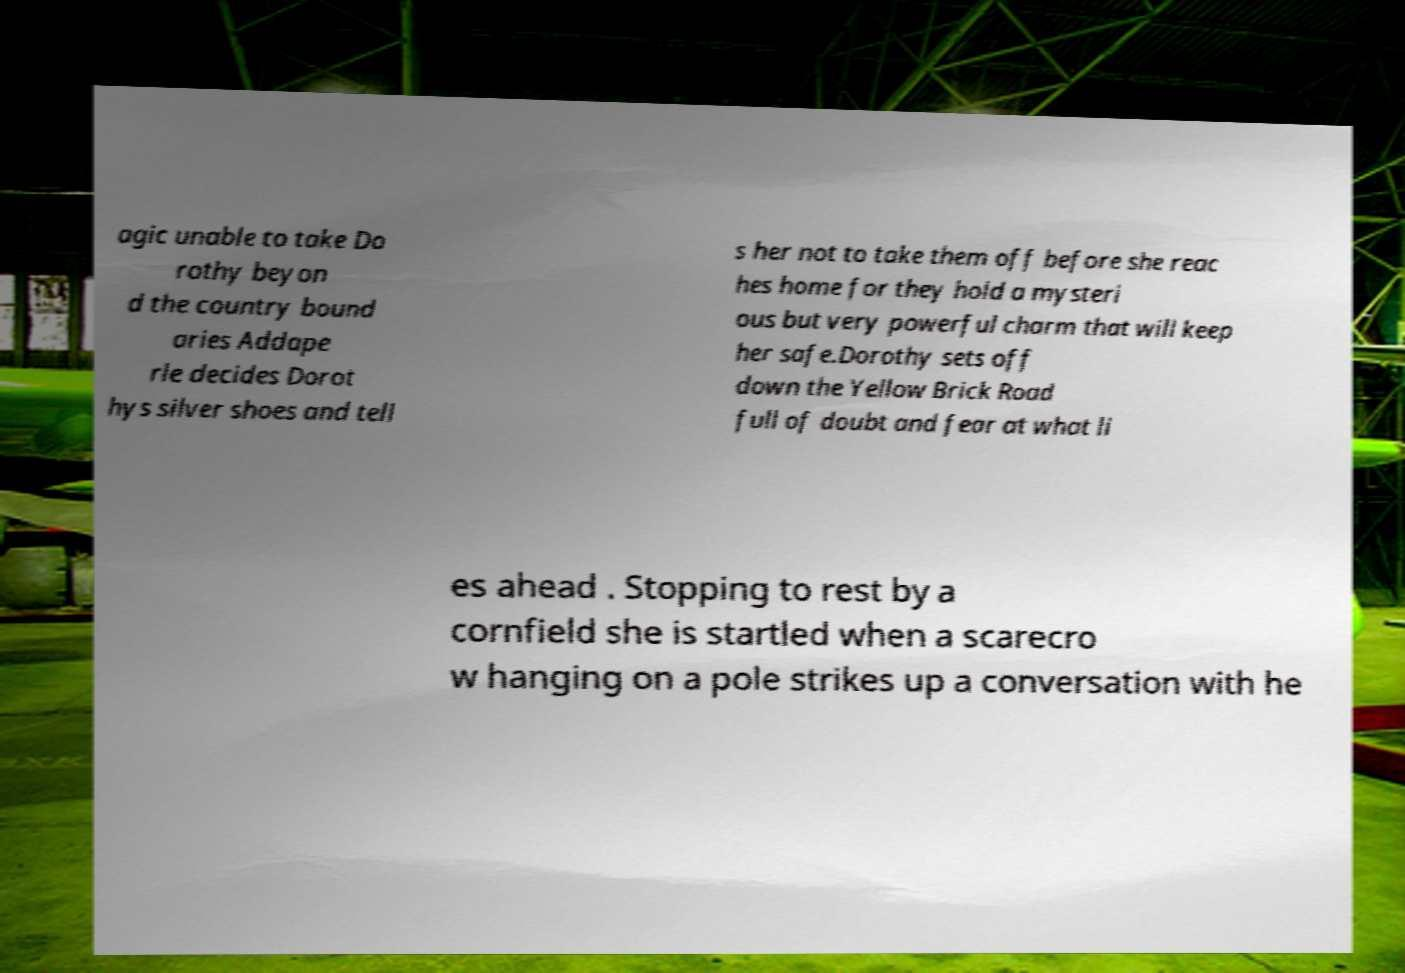I need the written content from this picture converted into text. Can you do that? agic unable to take Do rothy beyon d the country bound aries Addape rle decides Dorot hys silver shoes and tell s her not to take them off before she reac hes home for they hold a mysteri ous but very powerful charm that will keep her safe.Dorothy sets off down the Yellow Brick Road full of doubt and fear at what li es ahead . Stopping to rest by a cornfield she is startled when a scarecro w hanging on a pole strikes up a conversation with he 